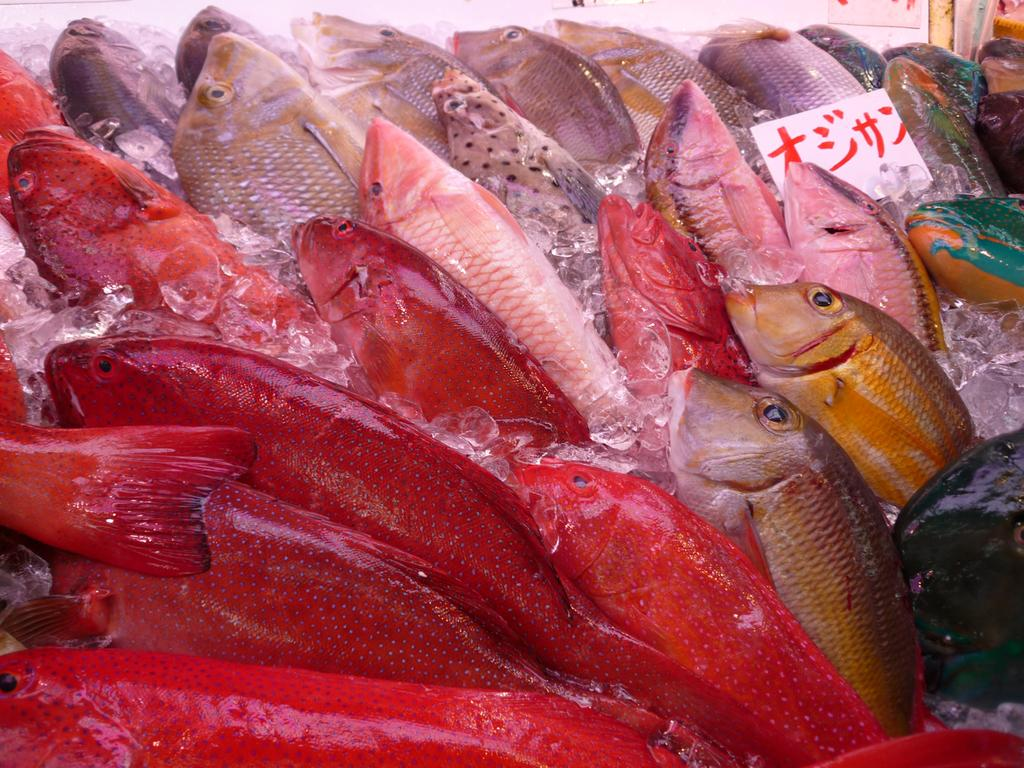What type of animals can be seen in the image? There are fishes in the image. What else is present in the image besides the fishes? There are ice pieces in the image. Can you describe the object on the right side of the image? There is a paper on the right side of the image. What is visible at the top of the image? There appears to be a wall at the top of the image. How many cats are sitting on the chairs in the image? There are no cats or chairs present in the image. What type of doll can be seen interacting with the fishes in the image? There is no doll present in the image; it only features fishes and ice pieces. 